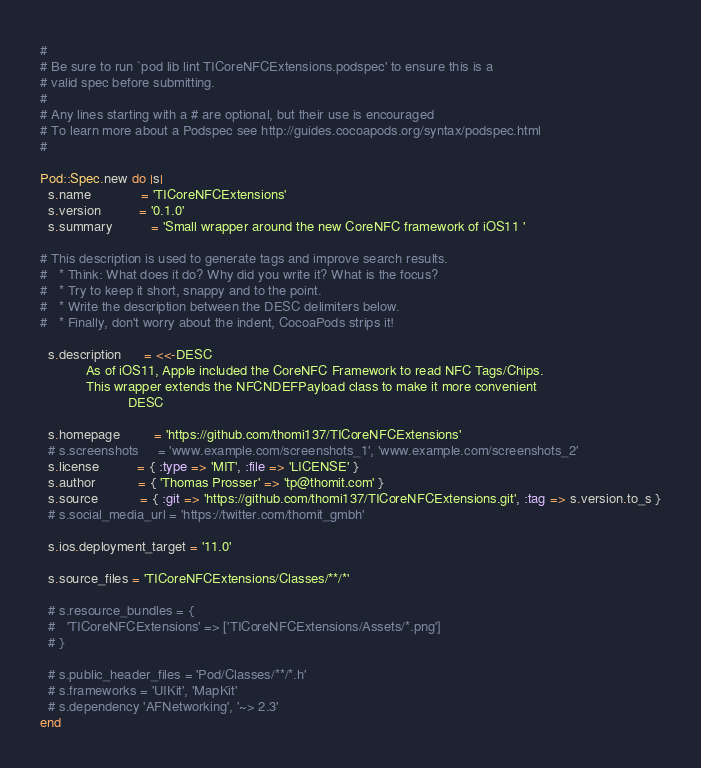<code> <loc_0><loc_0><loc_500><loc_500><_Ruby_>#
# Be sure to run `pod lib lint TICoreNFCExtensions.podspec' to ensure this is a
# valid spec before submitting.
#
# Any lines starting with a # are optional, but their use is encouraged
# To learn more about a Podspec see http://guides.cocoapods.org/syntax/podspec.html
#

Pod::Spec.new do |s|
  s.name             = 'TICoreNFCExtensions'
  s.version          = '0.1.0'
  s.summary          = 'Small wrapper around the new CoreNFC framework of iOS11 '

# This description is used to generate tags and improve search results.
#   * Think: What does it do? Why did you write it? What is the focus?
#   * Try to keep it short, snappy and to the point.
#   * Write the description between the DESC delimiters below.
#   * Finally, don't worry about the indent, CocoaPods strips it!

  s.description      = <<-DESC
			As of iOS11, Apple included the CoreNFC Framework to read NFC Tags/Chips.
			This wrapper extends the NFCNDEFPayload class to make it more convenient
                       DESC

  s.homepage         = 'https://github.com/thomi137/TICoreNFCExtensions'
  # s.screenshots     = 'www.example.com/screenshots_1', 'www.example.com/screenshots_2'
  s.license          = { :type => 'MIT', :file => 'LICENSE' }
  s.author           = { 'Thomas Prosser' => 'tp@thomit.com' }
  s.source           = { :git => 'https://github.com/thomi137/TICoreNFCExtensions.git', :tag => s.version.to_s }
  # s.social_media_url = 'https://twitter.com/thomit_gmbh'

  s.ios.deployment_target = '11.0'

  s.source_files = 'TICoreNFCExtensions/Classes/**/*'
  
  # s.resource_bundles = {
  #   'TICoreNFCExtensions' => ['TICoreNFCExtensions/Assets/*.png']
  # }

  # s.public_header_files = 'Pod/Classes/**/*.h'
  # s.frameworks = 'UIKit', 'MapKit'
  # s.dependency 'AFNetworking', '~> 2.3'
end
</code> 